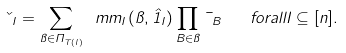Convert formula to latex. <formula><loc_0><loc_0><loc_500><loc_500>\kappa _ { I } = \sum _ { \pi \in \Pi _ { { T } ( I ) } } \ m m _ { I } ( \pi , \hat { 1 } _ { I } ) \prod _ { B \in \pi } \mu _ { B } \quad f o r a l l I \subseteq [ n ] .</formula> 